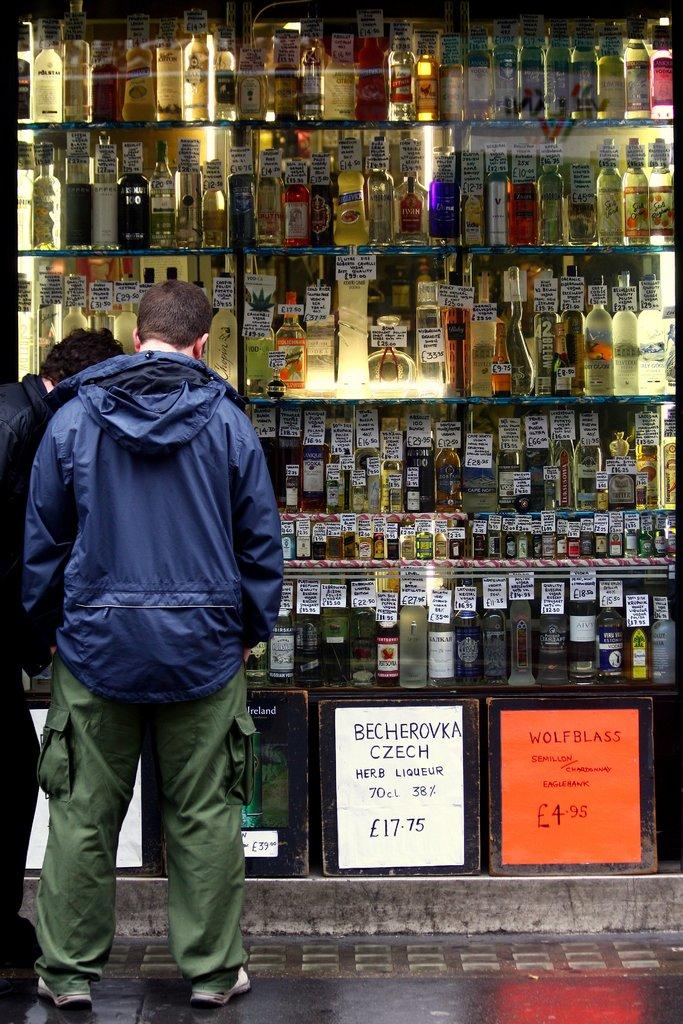What is the price on the white flyer at the bottom?
Give a very brief answer. 17.75. How much is the czech liquor?
Provide a succinct answer. 17.75. 